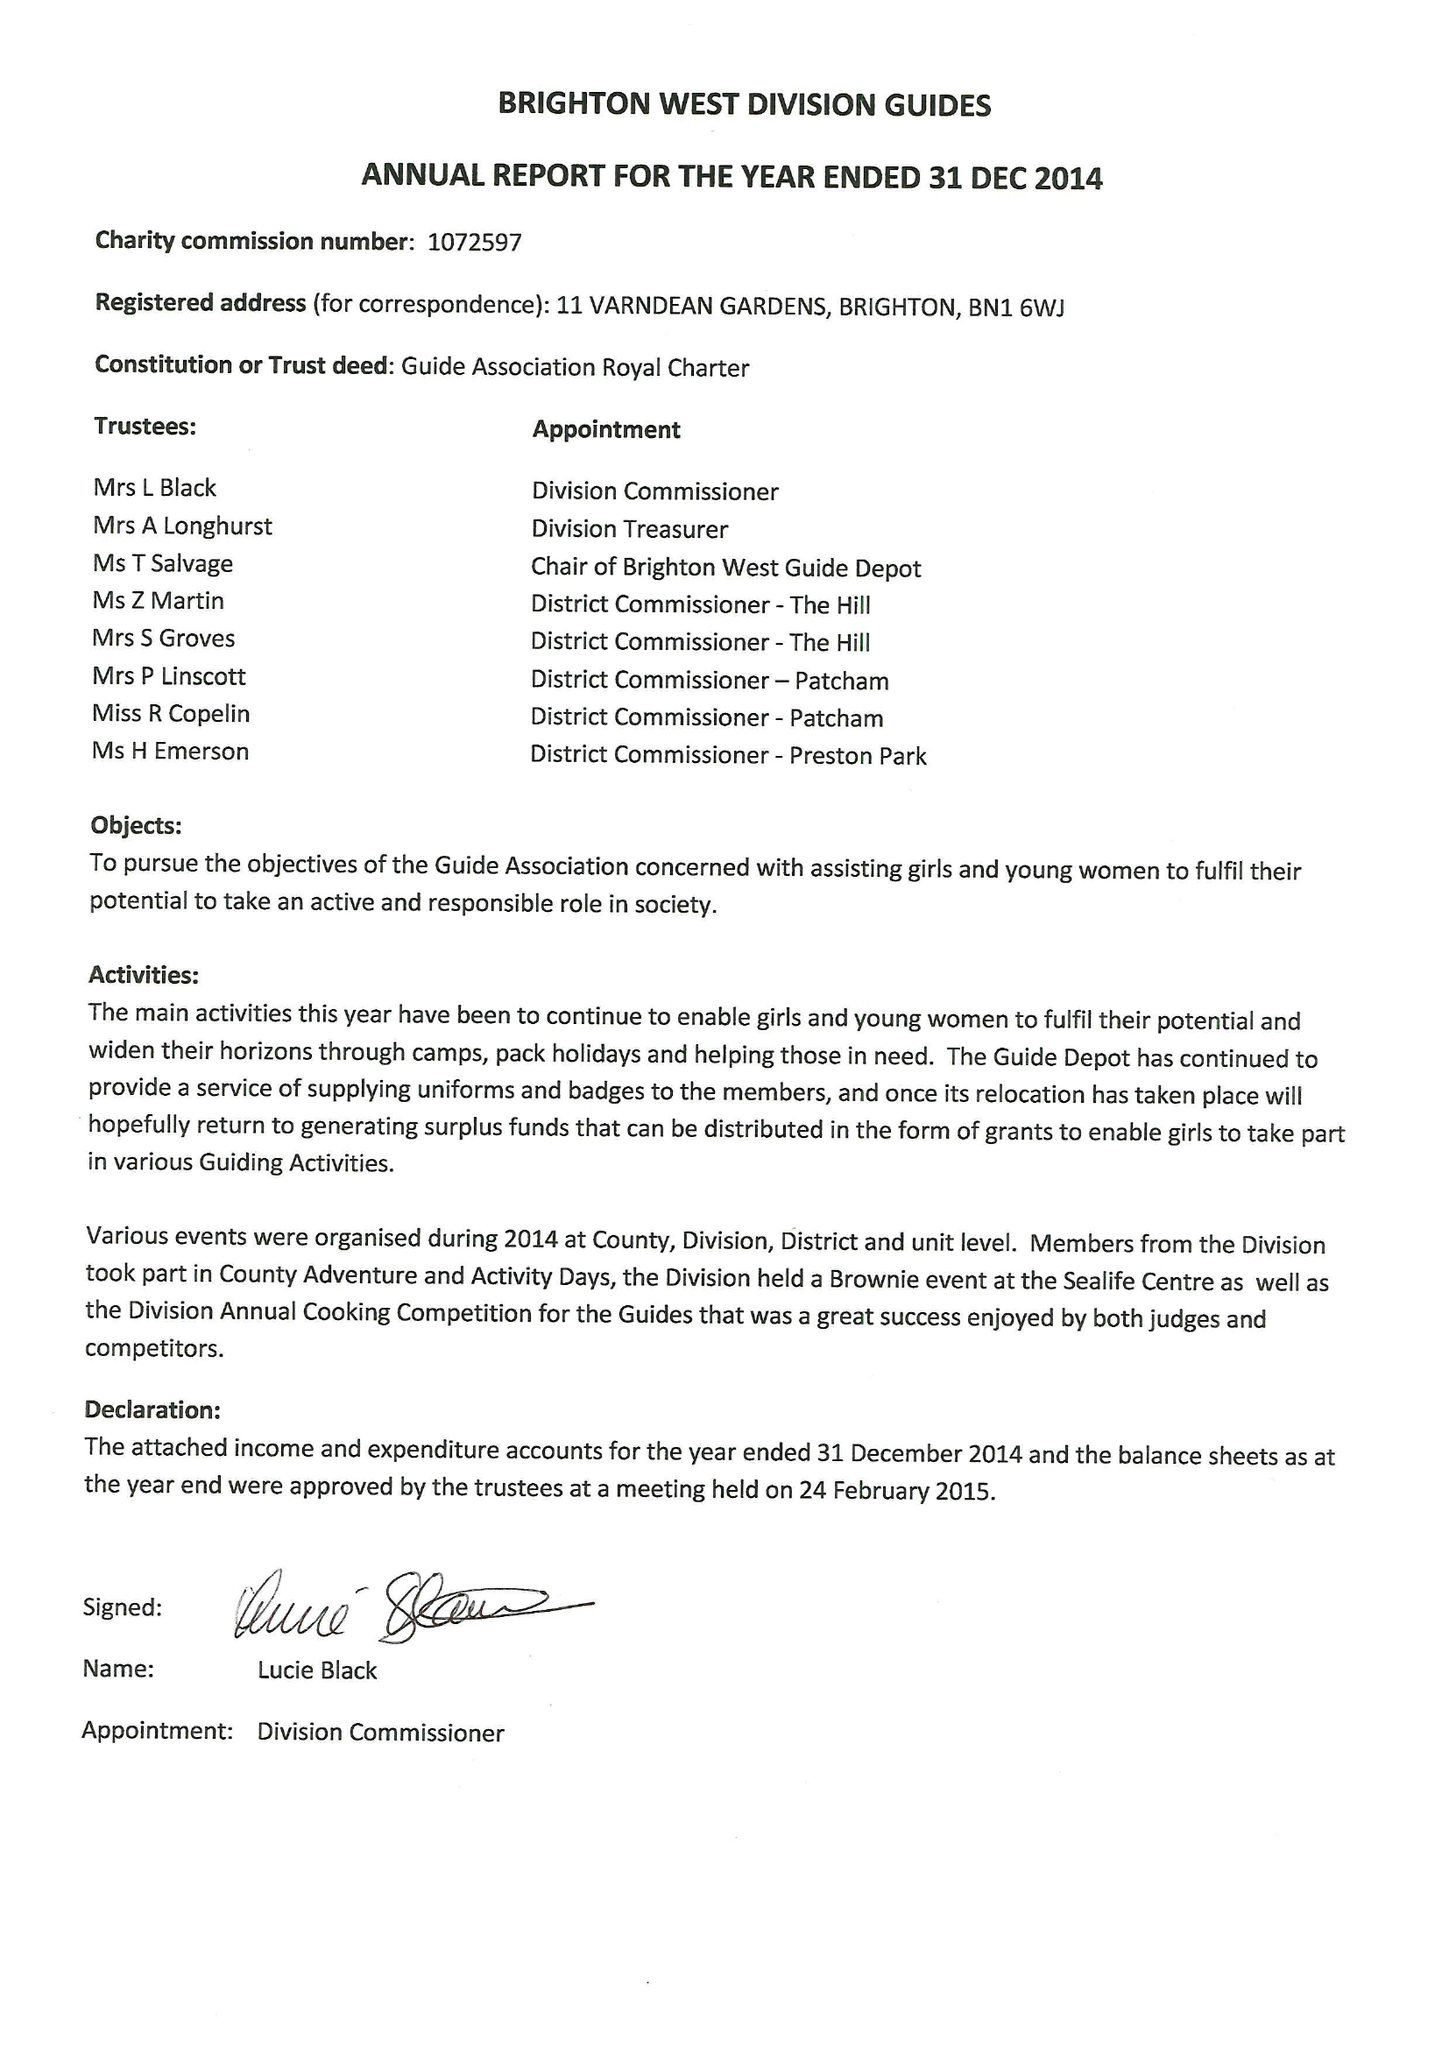What is the value for the charity_name?
Answer the question using a single word or phrase. Brighton West Division Guides 